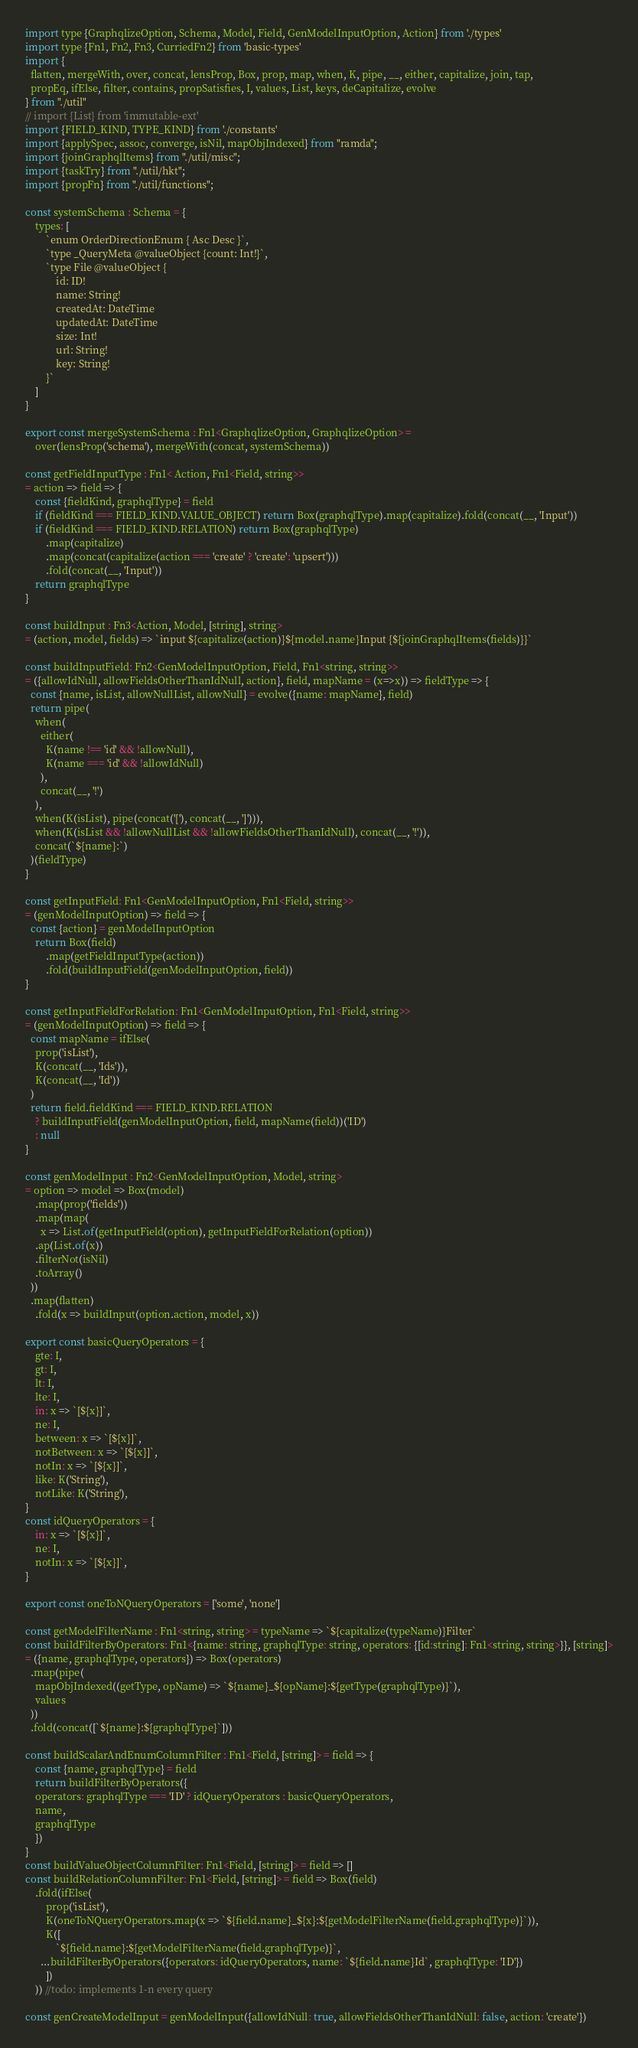Convert code to text. <code><loc_0><loc_0><loc_500><loc_500><_JavaScript_>import type {GraphqlizeOption, Schema, Model, Field, GenModelInputOption, Action} from './types'
import type {Fn1, Fn2, Fn3, CurriedFn2} from 'basic-types'
import {
  flatten, mergeWith, over, concat, lensProp, Box, prop, map, when, K, pipe, __, either, capitalize, join, tap,
  propEq, ifElse, filter, contains, propSatisfies, I, values, List, keys, deCapitalize, evolve
} from "./util"
// import {List} from 'immutable-ext'
import {FIELD_KIND, TYPE_KIND} from './constants'
import {applySpec, assoc, converge, isNil, mapObjIndexed} from "ramda";
import {joinGraphqlItems} from "./util/misc";
import {taskTry} from "./util/hkt";
import {propFn} from "./util/functions";

const systemSchema : Schema = {
	types: [
		`enum OrderDirectionEnum { Asc Desc }`,
		`type _QueryMeta @valueObject {count: Int!}`,
		`type File @valueObject {
			id: ID!
			name: String!
			createdAt: DateTime
			updatedAt: DateTime
			size: Int!
			url: String!
			key: String!
		}`
	]
}

export const mergeSystemSchema : Fn1<GraphqlizeOption, GraphqlizeOption> =
	over(lensProp('schema'), mergeWith(concat, systemSchema))

const getFieldInputType : Fn1< Action, Fn1<Field, string>>
= action => field => {
	const {fieldKind, graphqlType} = field
	if (fieldKind === FIELD_KIND.VALUE_OBJECT) return Box(graphqlType).map(capitalize).fold(concat(__, 'Input'))
	if (fieldKind === FIELD_KIND.RELATION) return Box(graphqlType)
		.map(capitalize)
		.map(concat(capitalize(action === 'create' ? 'create': 'upsert')))
		.fold(concat(__, 'Input'))
	return graphqlType
}

const buildInput : Fn3<Action, Model, [string], string>
= (action, model, fields) => `input ${capitalize(action)}${model.name}Input {${joinGraphqlItems(fields)}}`

const buildInputField: Fn2<GenModelInputOption, Field, Fn1<string, string>>
= ({allowIdNull, allowFieldsOtherThanIdNull, action}, field, mapName = (x=>x)) => fieldType => {
  const {name, isList, allowNullList, allowNull} = evolve({name: mapName}, field)
  return pipe(
    when(
      either(
        K(name !== 'id' && !allowNull),
        K(name === 'id' && !allowIdNull)
      ),
      concat(__, '!')
    ),
    when(K(isList), pipe(concat('['), concat(__, ']'))),
    when(K(isList && !allowNullList && !allowFieldsOtherThanIdNull), concat(__, '!')),
    concat(`${name}:`)
  )(fieldType)
}

const getInputField: Fn1<GenModelInputOption, Fn1<Field, string>>
= (genModelInputOption) => field => {
  const {action} = genModelInputOption
	return Box(field)
		.map(getFieldInputType(action))
		.fold(buildInputField(genModelInputOption, field))
}

const getInputFieldForRelation: Fn1<GenModelInputOption, Fn1<Field, string>>
= (genModelInputOption) => field => {
  const mapName = ifElse(
    prop('isList'),
    K(concat(__, 'Ids')),
    K(concat(__, 'Id'))
  )
  return field.fieldKind === FIELD_KIND.RELATION
    ? buildInputField(genModelInputOption, field, mapName(field))('ID')
    : null
}

const genModelInput : Fn2<GenModelInputOption, Model, string>
= option => model => Box(model)
	.map(prop('fields'))
	.map(map(
	  x => List.of(getInputField(option), getInputFieldForRelation(option))
    .ap(List.of(x))
    .filterNot(isNil)
    .toArray()
  ))
  .map(flatten)
	.fold(x => buildInput(option.action, model, x))

export const basicQueryOperators = {
	gte: I,
	gt: I,
	lt: I,
	lte: I,
	in: x => `[${x}]`,
	ne: I,
	between: x => `[${x}]`,
	notBetween: x => `[${x}]`,
	notIn: x => `[${x}]`,
	like: K('String'),
	notLike: K('String'),
}
const idQueryOperators = {
	in: x => `[${x}]`,
	ne: I,
	notIn: x => `[${x}]`,
}

export const oneToNQueryOperators = ['some', 'none']

const getModelFilterName : Fn1<string, string> = typeName => `${capitalize(typeName)}Filter`
const buildFilterByOperators: Fn1<{name: string, graphqlType: string, operators: {[id:string]: Fn1<string, string>}}, [string]>
= ({name, graphqlType, operators}) => Box(operators)
  .map(pipe(
    mapObjIndexed((getType, opName) => `${name}_${opName}:${getType(graphqlType)}`),
    values
  ))
  .fold(concat([`${name}:${graphqlType}`]))

const buildScalarAndEnumColumnFilter : Fn1<Field, [string]> = field => {
	const {name, graphqlType} = field
	return buildFilterByOperators({
    operators: graphqlType === 'ID' ? idQueryOperators : basicQueryOperators,
    name,
    graphqlType
	})
}
const buildValueObjectColumnFilter: Fn1<Field, [string]> = field => []
const buildRelationColumnFilter: Fn1<Field, [string]> = field => Box(field)
	.fold(ifElse(
		prop('isList'),
		K(oneToNQueryOperators.map(x => `${field.name}_${x}:${getModelFilterName(field.graphqlType)}`)),
		K([
			`${field.name}:${getModelFilterName(field.graphqlType)}`,
      ...buildFilterByOperators({operators: idQueryOperators, name: `${field.name}Id`, graphqlType: 'ID'})
		])
	)) //todo: implements 1-n every query

const genCreateModelInput = genModelInput({allowIdNull: true, allowFieldsOtherThanIdNull: false, action: 'create'})</code> 